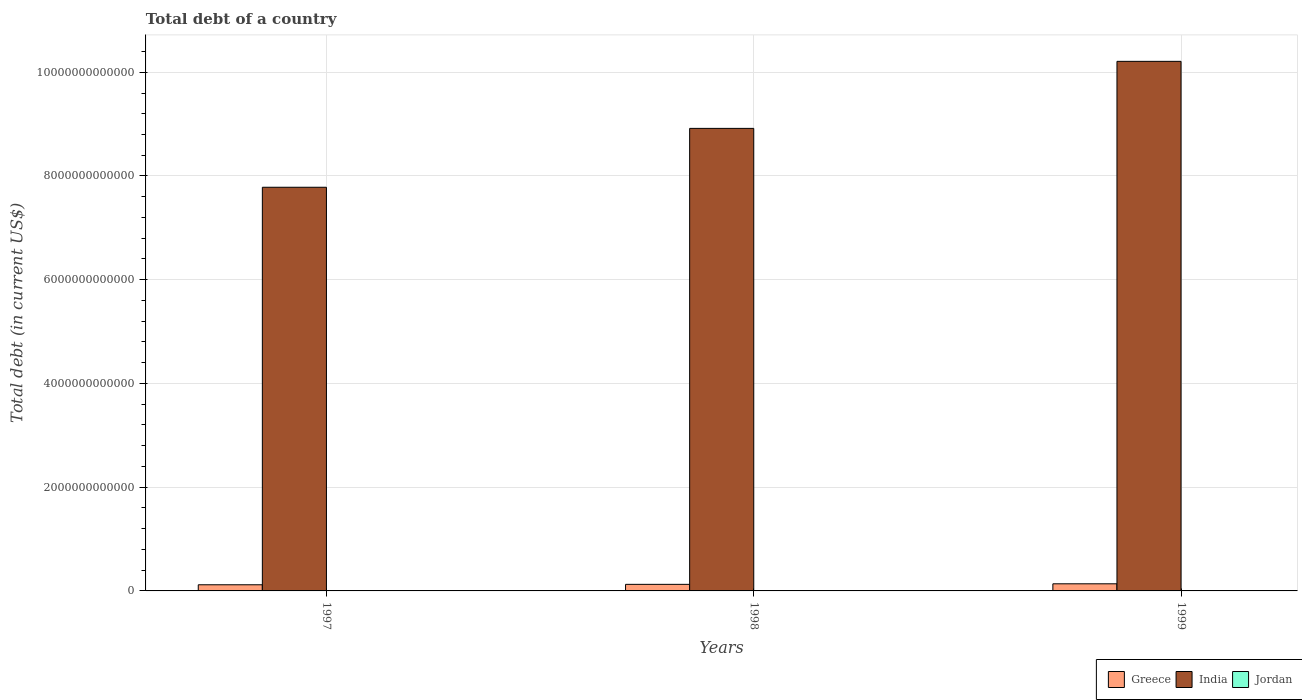How many different coloured bars are there?
Give a very brief answer. 3. How many groups of bars are there?
Make the answer very short. 3. Are the number of bars per tick equal to the number of legend labels?
Your answer should be compact. Yes. How many bars are there on the 2nd tick from the left?
Make the answer very short. 3. How many bars are there on the 3rd tick from the right?
Offer a very short reply. 3. What is the debt in Jordan in 1999?
Provide a short and direct response. 5.77e+09. Across all years, what is the maximum debt in India?
Provide a succinct answer. 1.02e+13. Across all years, what is the minimum debt in Jordan?
Your response must be concise. 5.16e+09. What is the total debt in Greece in the graph?
Offer a very short reply. 3.82e+11. What is the difference between the debt in Greece in 1997 and that in 1998?
Provide a short and direct response. -8.19e+09. What is the difference between the debt in India in 1997 and the debt in Greece in 1998?
Offer a terse response. 7.66e+12. What is the average debt in Jordan per year?
Offer a very short reply. 5.54e+09. In the year 1997, what is the difference between the debt in Greece and debt in India?
Keep it short and to the point. -7.66e+12. What is the ratio of the debt in Greece in 1998 to that in 1999?
Your answer should be compact. 0.92. Is the debt in India in 1997 less than that in 1998?
Give a very brief answer. Yes. Is the difference between the debt in Greece in 1997 and 1998 greater than the difference between the debt in India in 1997 and 1998?
Give a very brief answer. Yes. What is the difference between the highest and the second highest debt in Greece?
Keep it short and to the point. 1.08e+1. What is the difference between the highest and the lowest debt in Greece?
Offer a very short reply. 1.90e+1. In how many years, is the debt in Jordan greater than the average debt in Jordan taken over all years?
Ensure brevity in your answer.  2. What does the 3rd bar from the right in 1997 represents?
Make the answer very short. Greece. Is it the case that in every year, the sum of the debt in India and debt in Jordan is greater than the debt in Greece?
Offer a terse response. Yes. How many bars are there?
Offer a very short reply. 9. How many years are there in the graph?
Provide a succinct answer. 3. What is the difference between two consecutive major ticks on the Y-axis?
Offer a very short reply. 2.00e+12. Does the graph contain grids?
Your answer should be compact. Yes. How are the legend labels stacked?
Offer a terse response. Horizontal. What is the title of the graph?
Provide a short and direct response. Total debt of a country. Does "Venezuela" appear as one of the legend labels in the graph?
Provide a short and direct response. No. What is the label or title of the X-axis?
Offer a terse response. Years. What is the label or title of the Y-axis?
Offer a very short reply. Total debt (in current US$). What is the Total debt (in current US$) in Greece in 1997?
Offer a very short reply. 1.18e+11. What is the Total debt (in current US$) of India in 1997?
Provide a short and direct response. 7.78e+12. What is the Total debt (in current US$) in Jordan in 1997?
Your response must be concise. 5.16e+09. What is the Total debt (in current US$) of Greece in 1998?
Your response must be concise. 1.27e+11. What is the Total debt (in current US$) of India in 1998?
Provide a succinct answer. 8.92e+12. What is the Total debt (in current US$) of Jordan in 1998?
Provide a succinct answer. 5.68e+09. What is the Total debt (in current US$) in Greece in 1999?
Offer a very short reply. 1.37e+11. What is the Total debt (in current US$) in India in 1999?
Offer a terse response. 1.02e+13. What is the Total debt (in current US$) of Jordan in 1999?
Give a very brief answer. 5.77e+09. Across all years, what is the maximum Total debt (in current US$) of Greece?
Ensure brevity in your answer.  1.37e+11. Across all years, what is the maximum Total debt (in current US$) in India?
Offer a terse response. 1.02e+13. Across all years, what is the maximum Total debt (in current US$) of Jordan?
Offer a terse response. 5.77e+09. Across all years, what is the minimum Total debt (in current US$) of Greece?
Provide a succinct answer. 1.18e+11. Across all years, what is the minimum Total debt (in current US$) in India?
Ensure brevity in your answer.  7.78e+12. Across all years, what is the minimum Total debt (in current US$) of Jordan?
Your response must be concise. 5.16e+09. What is the total Total debt (in current US$) in Greece in the graph?
Offer a very short reply. 3.82e+11. What is the total Total debt (in current US$) in India in the graph?
Ensure brevity in your answer.  2.69e+13. What is the total Total debt (in current US$) in Jordan in the graph?
Offer a terse response. 1.66e+1. What is the difference between the Total debt (in current US$) of Greece in 1997 and that in 1998?
Make the answer very short. -8.19e+09. What is the difference between the Total debt (in current US$) of India in 1997 and that in 1998?
Your answer should be compact. -1.14e+12. What is the difference between the Total debt (in current US$) of Jordan in 1997 and that in 1998?
Give a very brief answer. -5.18e+08. What is the difference between the Total debt (in current US$) of Greece in 1997 and that in 1999?
Keep it short and to the point. -1.90e+1. What is the difference between the Total debt (in current US$) of India in 1997 and that in 1999?
Provide a short and direct response. -2.43e+12. What is the difference between the Total debt (in current US$) in Jordan in 1997 and that in 1999?
Provide a succinct answer. -6.16e+08. What is the difference between the Total debt (in current US$) in Greece in 1998 and that in 1999?
Offer a very short reply. -1.08e+1. What is the difference between the Total debt (in current US$) in India in 1998 and that in 1999?
Provide a succinct answer. -1.29e+12. What is the difference between the Total debt (in current US$) in Jordan in 1998 and that in 1999?
Provide a succinct answer. -9.73e+07. What is the difference between the Total debt (in current US$) of Greece in 1997 and the Total debt (in current US$) of India in 1998?
Ensure brevity in your answer.  -8.80e+12. What is the difference between the Total debt (in current US$) of Greece in 1997 and the Total debt (in current US$) of Jordan in 1998?
Make the answer very short. 1.13e+11. What is the difference between the Total debt (in current US$) of India in 1997 and the Total debt (in current US$) of Jordan in 1998?
Your answer should be compact. 7.78e+12. What is the difference between the Total debt (in current US$) in Greece in 1997 and the Total debt (in current US$) in India in 1999?
Keep it short and to the point. -1.01e+13. What is the difference between the Total debt (in current US$) of Greece in 1997 and the Total debt (in current US$) of Jordan in 1999?
Keep it short and to the point. 1.13e+11. What is the difference between the Total debt (in current US$) in India in 1997 and the Total debt (in current US$) in Jordan in 1999?
Keep it short and to the point. 7.78e+12. What is the difference between the Total debt (in current US$) in Greece in 1998 and the Total debt (in current US$) in India in 1999?
Offer a very short reply. -1.01e+13. What is the difference between the Total debt (in current US$) in Greece in 1998 and the Total debt (in current US$) in Jordan in 1999?
Ensure brevity in your answer.  1.21e+11. What is the difference between the Total debt (in current US$) in India in 1998 and the Total debt (in current US$) in Jordan in 1999?
Ensure brevity in your answer.  8.91e+12. What is the average Total debt (in current US$) in Greece per year?
Offer a terse response. 1.27e+11. What is the average Total debt (in current US$) of India per year?
Your response must be concise. 8.97e+12. What is the average Total debt (in current US$) of Jordan per year?
Make the answer very short. 5.54e+09. In the year 1997, what is the difference between the Total debt (in current US$) of Greece and Total debt (in current US$) of India?
Your answer should be very brief. -7.66e+12. In the year 1997, what is the difference between the Total debt (in current US$) in Greece and Total debt (in current US$) in Jordan?
Make the answer very short. 1.13e+11. In the year 1997, what is the difference between the Total debt (in current US$) of India and Total debt (in current US$) of Jordan?
Give a very brief answer. 7.78e+12. In the year 1998, what is the difference between the Total debt (in current US$) in Greece and Total debt (in current US$) in India?
Ensure brevity in your answer.  -8.79e+12. In the year 1998, what is the difference between the Total debt (in current US$) of Greece and Total debt (in current US$) of Jordan?
Provide a short and direct response. 1.21e+11. In the year 1998, what is the difference between the Total debt (in current US$) of India and Total debt (in current US$) of Jordan?
Your response must be concise. 8.91e+12. In the year 1999, what is the difference between the Total debt (in current US$) in Greece and Total debt (in current US$) in India?
Keep it short and to the point. -1.01e+13. In the year 1999, what is the difference between the Total debt (in current US$) in Greece and Total debt (in current US$) in Jordan?
Give a very brief answer. 1.32e+11. In the year 1999, what is the difference between the Total debt (in current US$) of India and Total debt (in current US$) of Jordan?
Your answer should be very brief. 1.02e+13. What is the ratio of the Total debt (in current US$) of Greece in 1997 to that in 1998?
Make the answer very short. 0.94. What is the ratio of the Total debt (in current US$) of India in 1997 to that in 1998?
Your response must be concise. 0.87. What is the ratio of the Total debt (in current US$) of Jordan in 1997 to that in 1998?
Your answer should be very brief. 0.91. What is the ratio of the Total debt (in current US$) in Greece in 1997 to that in 1999?
Your answer should be very brief. 0.86. What is the ratio of the Total debt (in current US$) of India in 1997 to that in 1999?
Your response must be concise. 0.76. What is the ratio of the Total debt (in current US$) in Jordan in 1997 to that in 1999?
Provide a succinct answer. 0.89. What is the ratio of the Total debt (in current US$) of Greece in 1998 to that in 1999?
Your response must be concise. 0.92. What is the ratio of the Total debt (in current US$) of India in 1998 to that in 1999?
Your response must be concise. 0.87. What is the ratio of the Total debt (in current US$) of Jordan in 1998 to that in 1999?
Ensure brevity in your answer.  0.98. What is the difference between the highest and the second highest Total debt (in current US$) of Greece?
Offer a very short reply. 1.08e+1. What is the difference between the highest and the second highest Total debt (in current US$) in India?
Offer a terse response. 1.29e+12. What is the difference between the highest and the second highest Total debt (in current US$) of Jordan?
Offer a very short reply. 9.73e+07. What is the difference between the highest and the lowest Total debt (in current US$) of Greece?
Ensure brevity in your answer.  1.90e+1. What is the difference between the highest and the lowest Total debt (in current US$) in India?
Offer a very short reply. 2.43e+12. What is the difference between the highest and the lowest Total debt (in current US$) of Jordan?
Your answer should be very brief. 6.16e+08. 